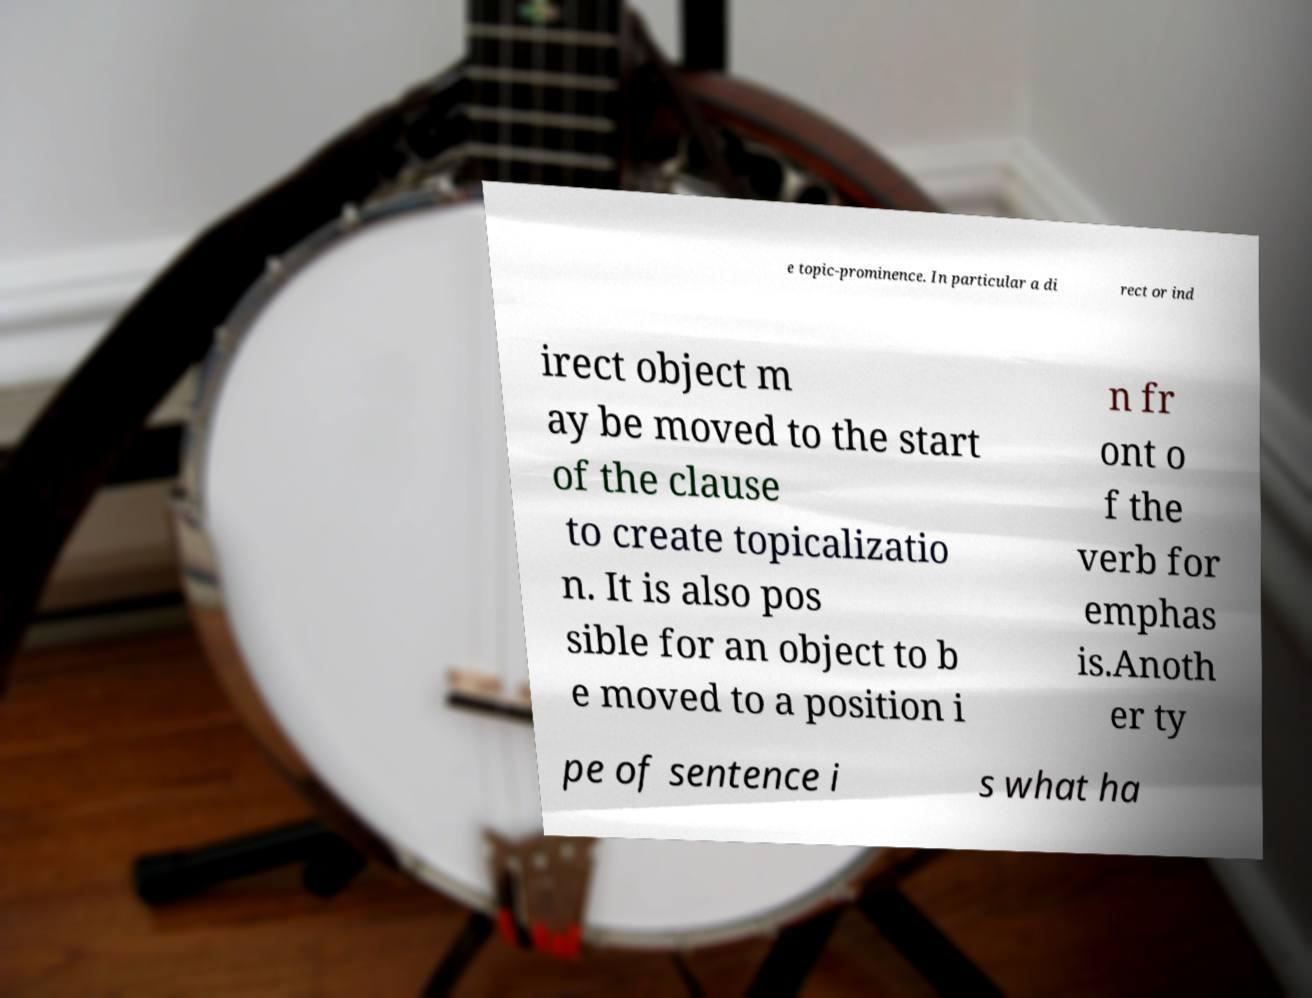What messages or text are displayed in this image? I need them in a readable, typed format. e topic-prominence. In particular a di rect or ind irect object m ay be moved to the start of the clause to create topicalizatio n. It is also pos sible for an object to b e moved to a position i n fr ont o f the verb for emphas is.Anoth er ty pe of sentence i s what ha 